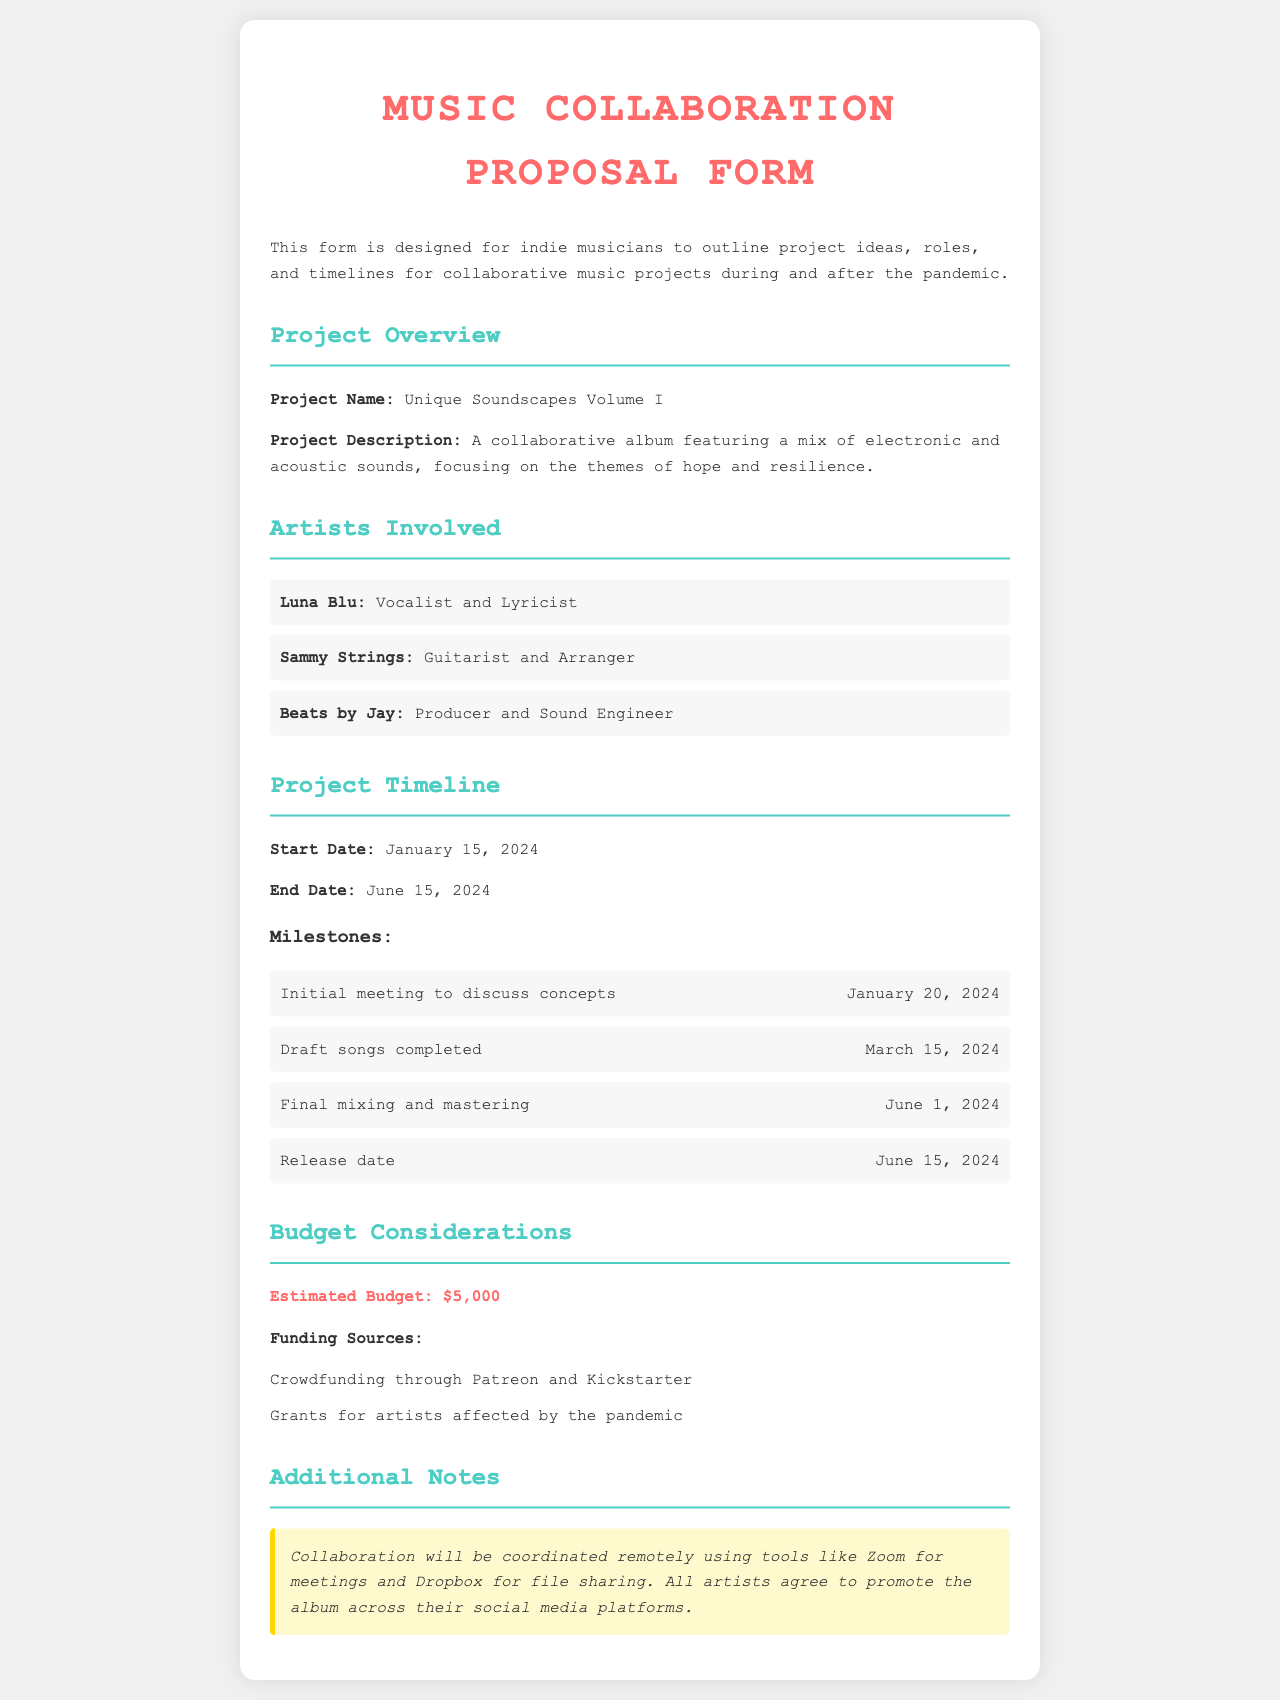What is the project name? The project name is specifically mentioned in the document's overview section.
Answer: Unique Soundscapes Volume I Who is the vocalists and lyricist? The specific role of the artist is listed under the "Artists Involved" section.
Answer: Luna Blu What is the estimated budget? The estimated budget is clearly stated in the "Budget Considerations" section.
Answer: $5,000 What is the release date? The release date is highlighted in the project timeline section of the document.
Answer: June 15, 2024 On what date are the draft songs expected to be completed? The date for this milestone is given under the "Project Timeline" section.
Answer: March 15, 2024 What is the primary theme of the project? The themes of the project are outlined in the project description segment.
Answer: Hope and resilience Which platforms will be used for collaboration? The document provides specific tools for coordination in the additional notes section.
Answer: Zoom and Dropbox How many milestones are listed in the project timeline? The total number of milestones can be counted in the project timeline section.
Answer: 4 